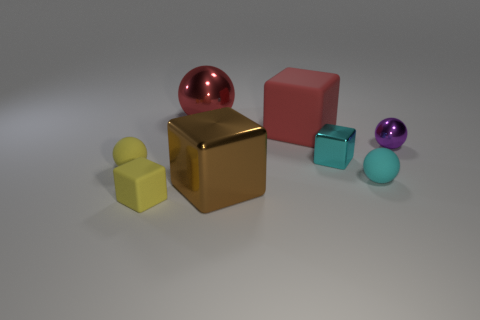Subtract 1 cubes. How many cubes are left? 3 Add 1 yellow spheres. How many objects exist? 9 Add 6 big red cubes. How many big red cubes are left? 7 Add 2 large brown metallic blocks. How many large brown metallic blocks exist? 3 Subtract 0 blue cylinders. How many objects are left? 8 Subtract all big yellow cubes. Subtract all large balls. How many objects are left? 7 